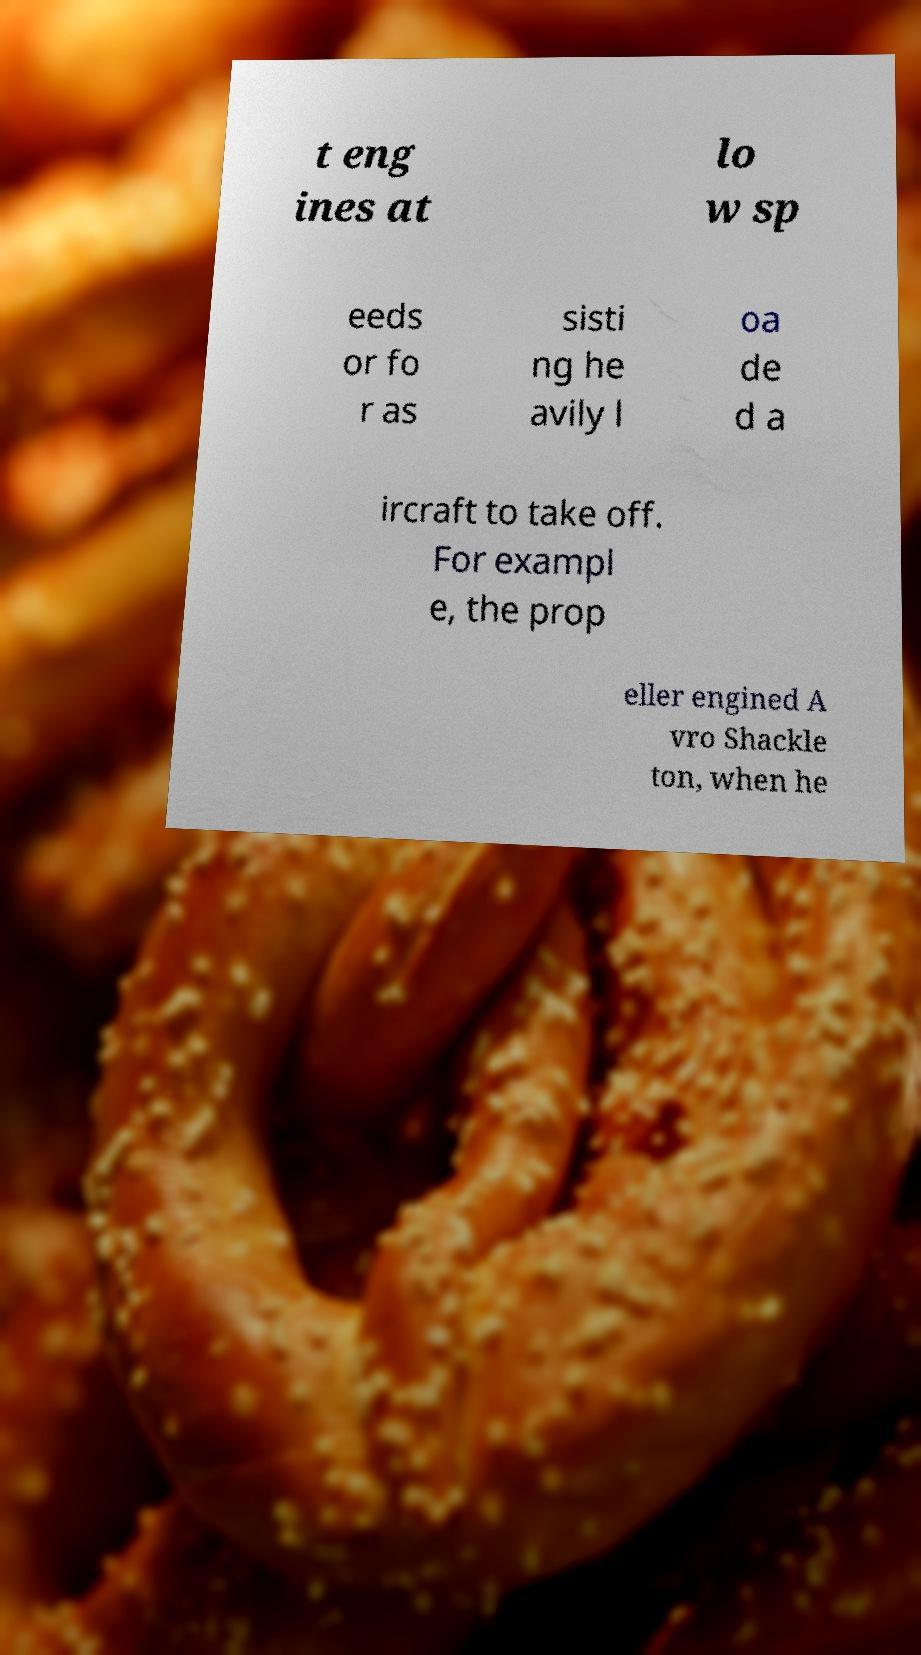For documentation purposes, I need the text within this image transcribed. Could you provide that? t eng ines at lo w sp eeds or fo r as sisti ng he avily l oa de d a ircraft to take off. For exampl e, the prop eller engined A vro Shackle ton, when he 